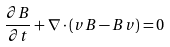Convert formula to latex. <formula><loc_0><loc_0><loc_500><loc_500>\frac { \partial { B } } { \partial t } + \nabla \cdot ( { v B - B v } ) = 0</formula> 